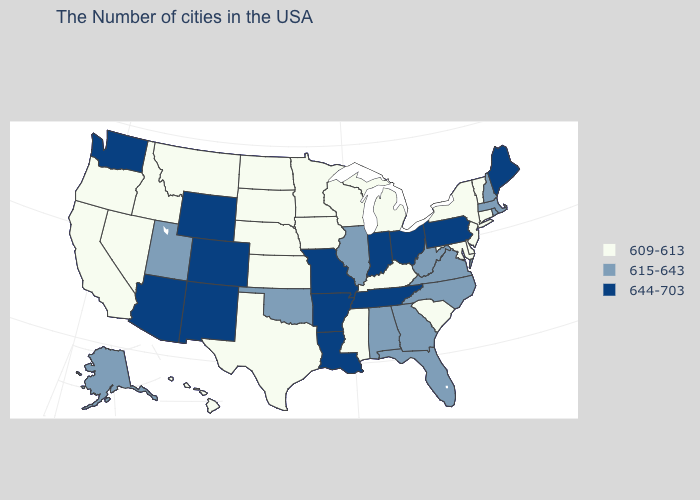What is the value of Georgia?
Quick response, please. 615-643. Is the legend a continuous bar?
Be succinct. No. Does the first symbol in the legend represent the smallest category?
Quick response, please. Yes. Does West Virginia have the same value as Rhode Island?
Keep it brief. Yes. Does Nevada have the same value as Minnesota?
Keep it brief. Yes. Name the states that have a value in the range 615-643?
Give a very brief answer. Massachusetts, Rhode Island, New Hampshire, Virginia, North Carolina, West Virginia, Florida, Georgia, Alabama, Illinois, Oklahoma, Utah, Alaska. Is the legend a continuous bar?
Answer briefly. No. Does Maine have the lowest value in the USA?
Be succinct. No. Is the legend a continuous bar?
Write a very short answer. No. Name the states that have a value in the range 609-613?
Keep it brief. Vermont, Connecticut, New York, New Jersey, Delaware, Maryland, South Carolina, Michigan, Kentucky, Wisconsin, Mississippi, Minnesota, Iowa, Kansas, Nebraska, Texas, South Dakota, North Dakota, Montana, Idaho, Nevada, California, Oregon, Hawaii. Does the map have missing data?
Write a very short answer. No. Does Mississippi have the lowest value in the South?
Concise answer only. Yes. Does Utah have a higher value than Kansas?
Concise answer only. Yes. 